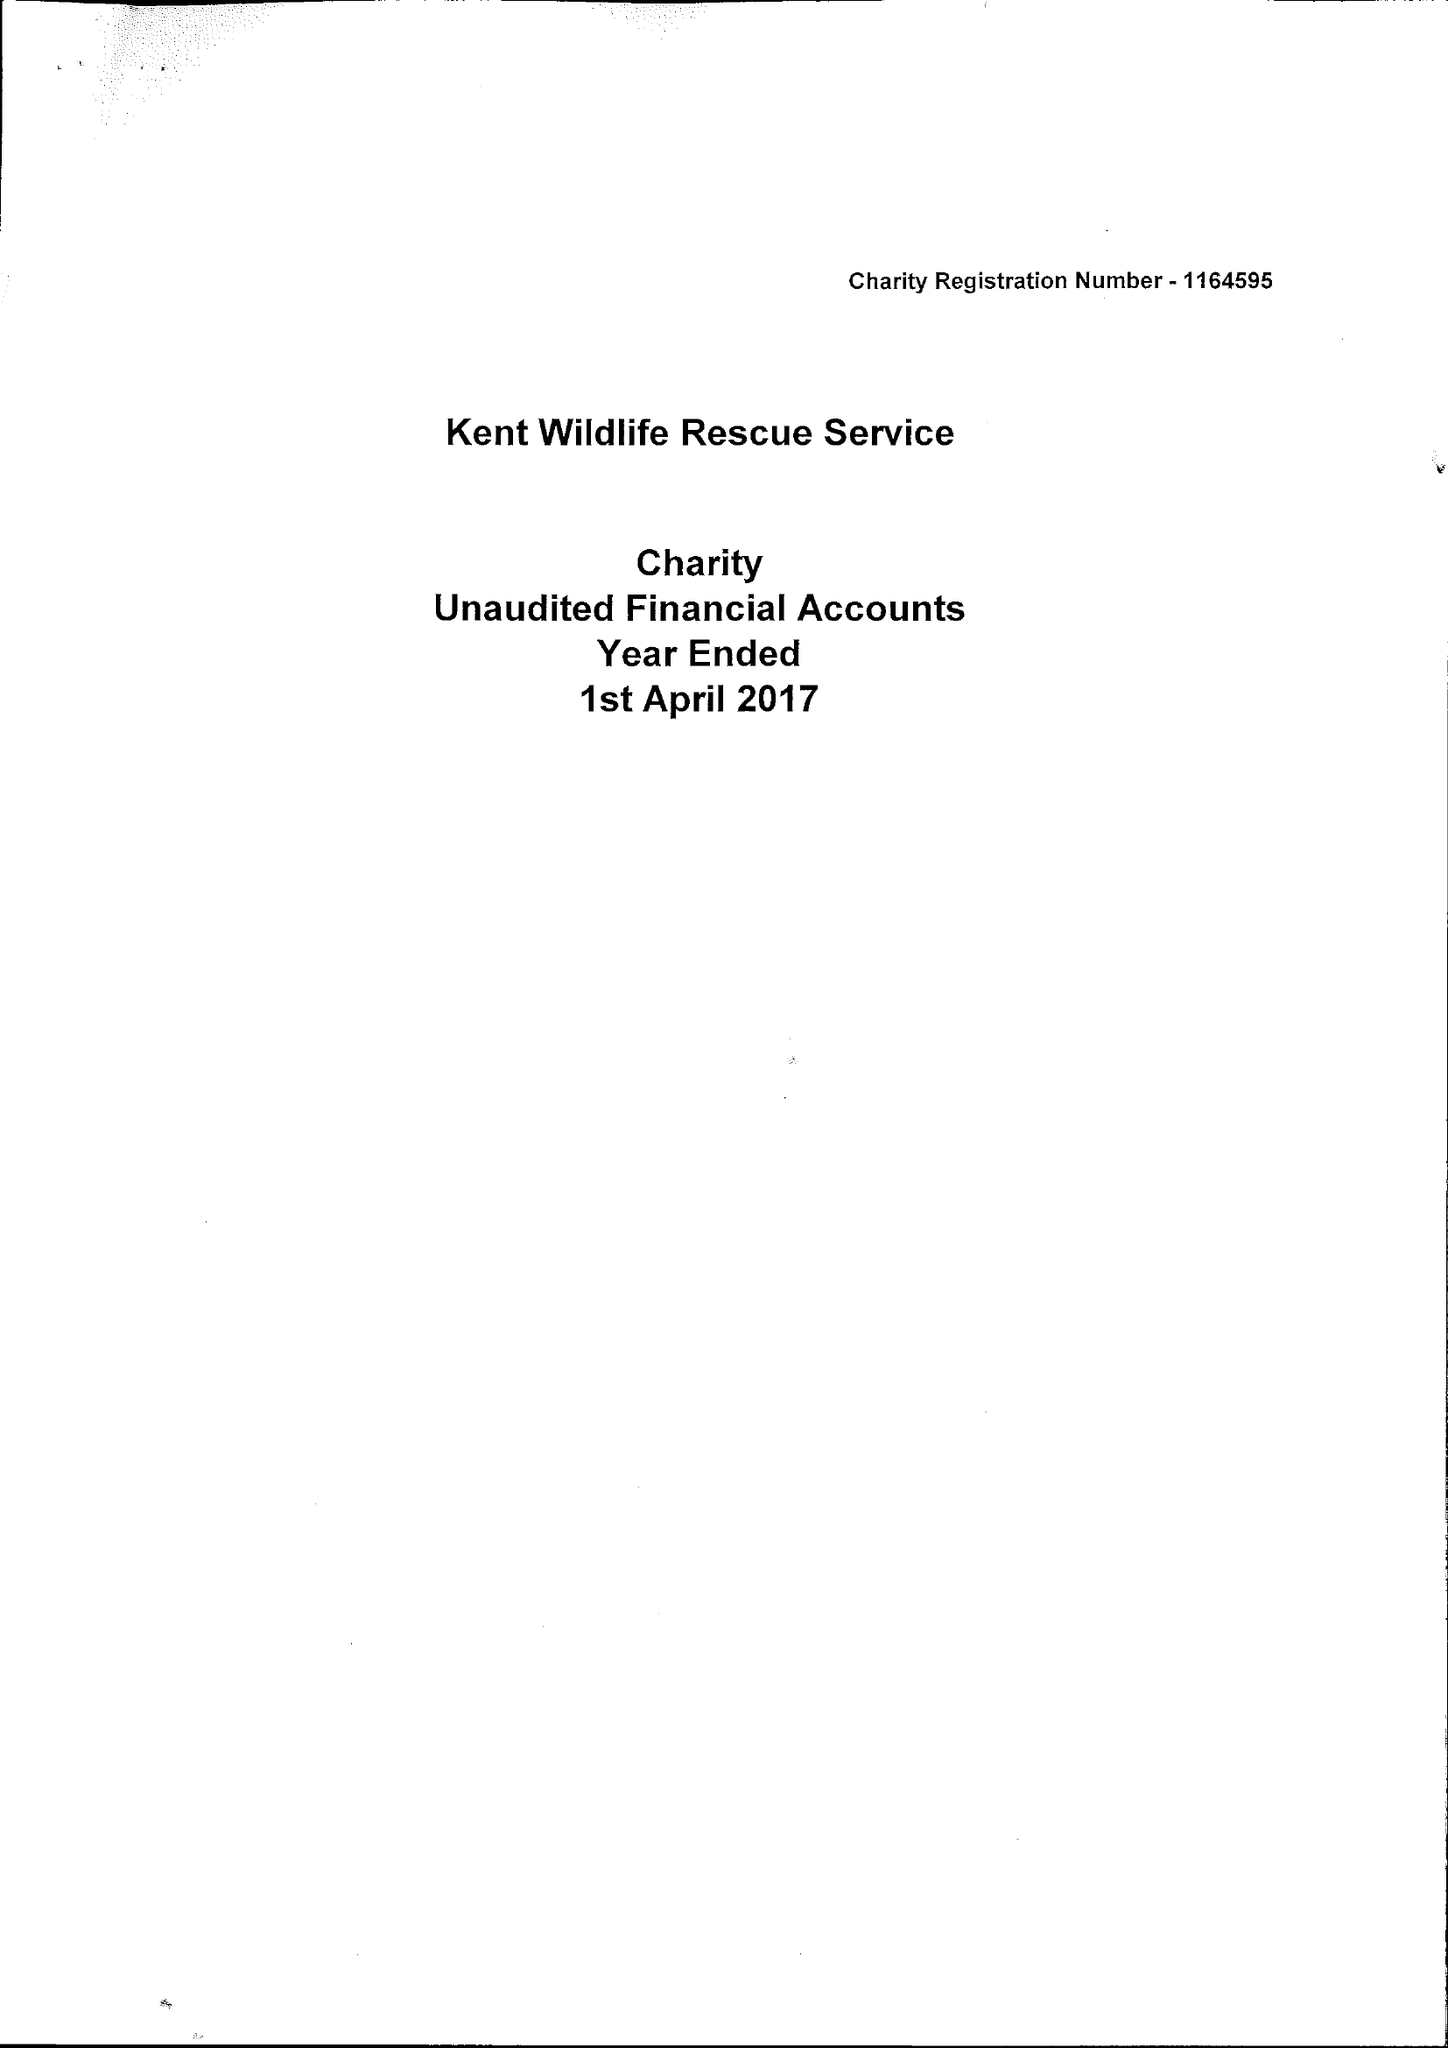What is the value for the address__street_line?
Answer the question using a single word or phrase. 106 VICTORIA STREET 